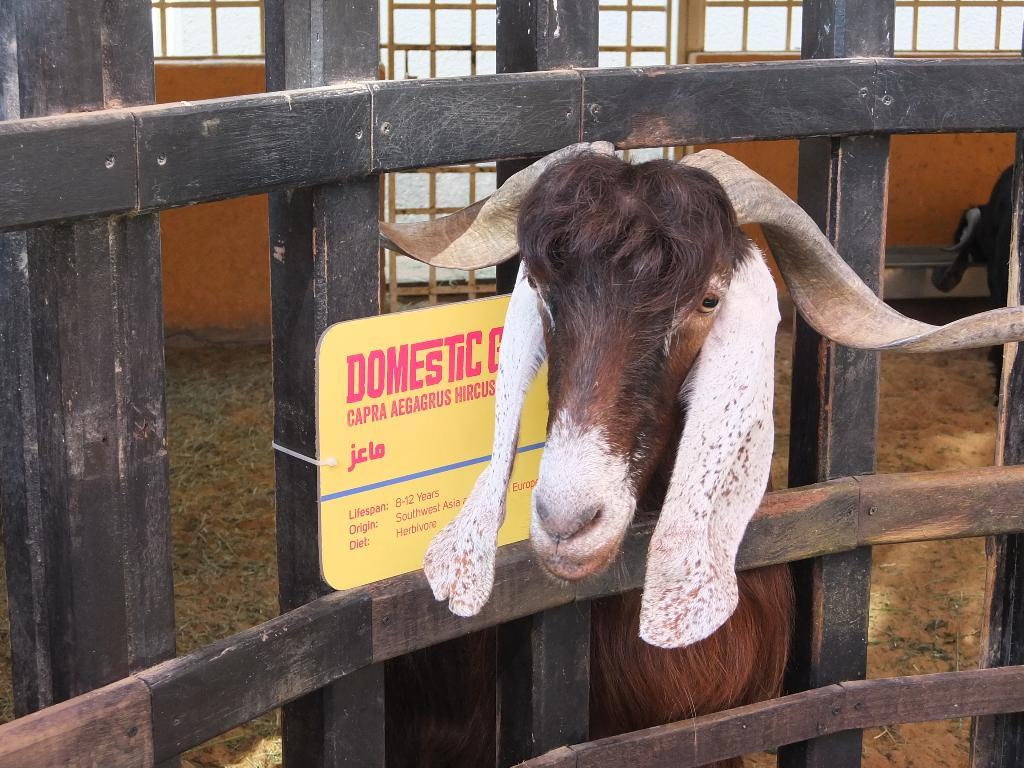What type of animal is present in the image? There is a goat in the image. What object can be seen in the image besides the goat? There is a board in the image. What type of barrier is visible in the image? There is a fence in the image. What can be seen in the background of the image? There are windows visible in the background of the image. What type of tongue can be seen on the goat in the image? There is no tongue visible on the goat in the image. What type of lock is present on the board in the image? There is no lock present on the board in the image. How many chairs are visible in the image? There are no chairs visible in the image. 